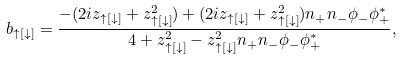Convert formula to latex. <formula><loc_0><loc_0><loc_500><loc_500>b _ { \uparrow [ \downarrow ] } = \frac { - ( 2 i z _ { \uparrow [ \downarrow ] } + z _ { \uparrow [ \downarrow ] } ^ { 2 } ) + ( 2 i z _ { \uparrow [ \downarrow ] } + z _ { \uparrow [ \downarrow ] } ^ { 2 } ) n _ { + } n _ { - } \phi _ { - } \phi _ { + } ^ { \ast } } { 4 + z _ { \uparrow [ \downarrow ] } ^ { 2 } - z _ { \uparrow [ \downarrow ] } ^ { 2 } n _ { + } n _ { - } \phi _ { - } \phi _ { + } ^ { \ast } } ,</formula> 